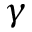Convert formula to latex. <formula><loc_0><loc_0><loc_500><loc_500>\gamma</formula> 